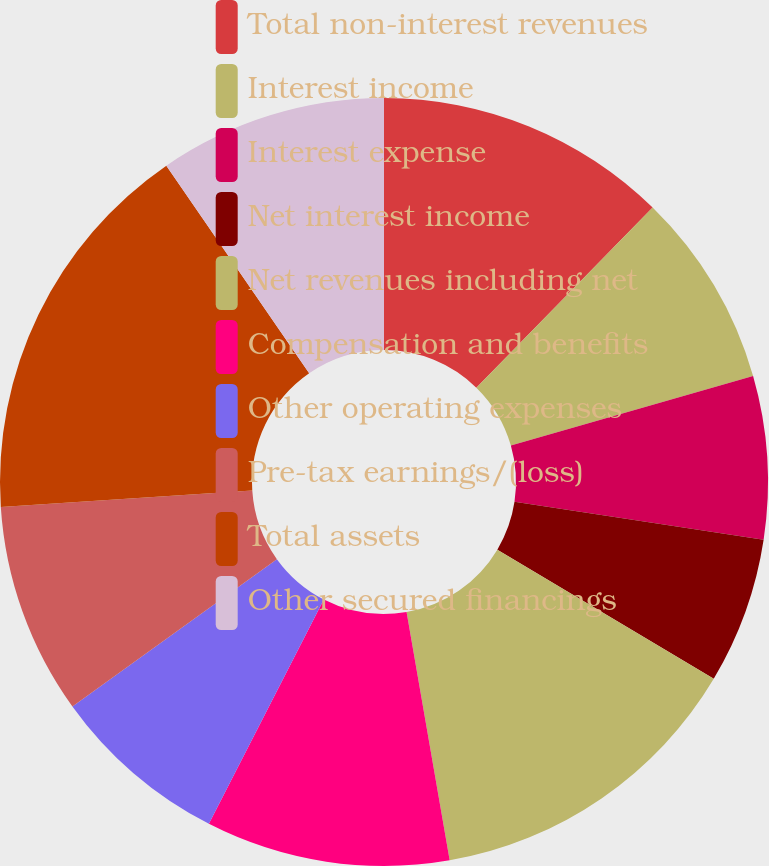<chart> <loc_0><loc_0><loc_500><loc_500><pie_chart><fcel>Total non-interest revenues<fcel>Interest income<fcel>Interest expense<fcel>Net interest income<fcel>Net revenues including net<fcel>Compensation and benefits<fcel>Other operating expenses<fcel>Pre-tax earnings/(loss)<fcel>Total assets<fcel>Other secured financings<nl><fcel>12.33%<fcel>8.22%<fcel>6.85%<fcel>6.16%<fcel>13.7%<fcel>10.27%<fcel>7.53%<fcel>8.9%<fcel>16.44%<fcel>9.59%<nl></chart> 